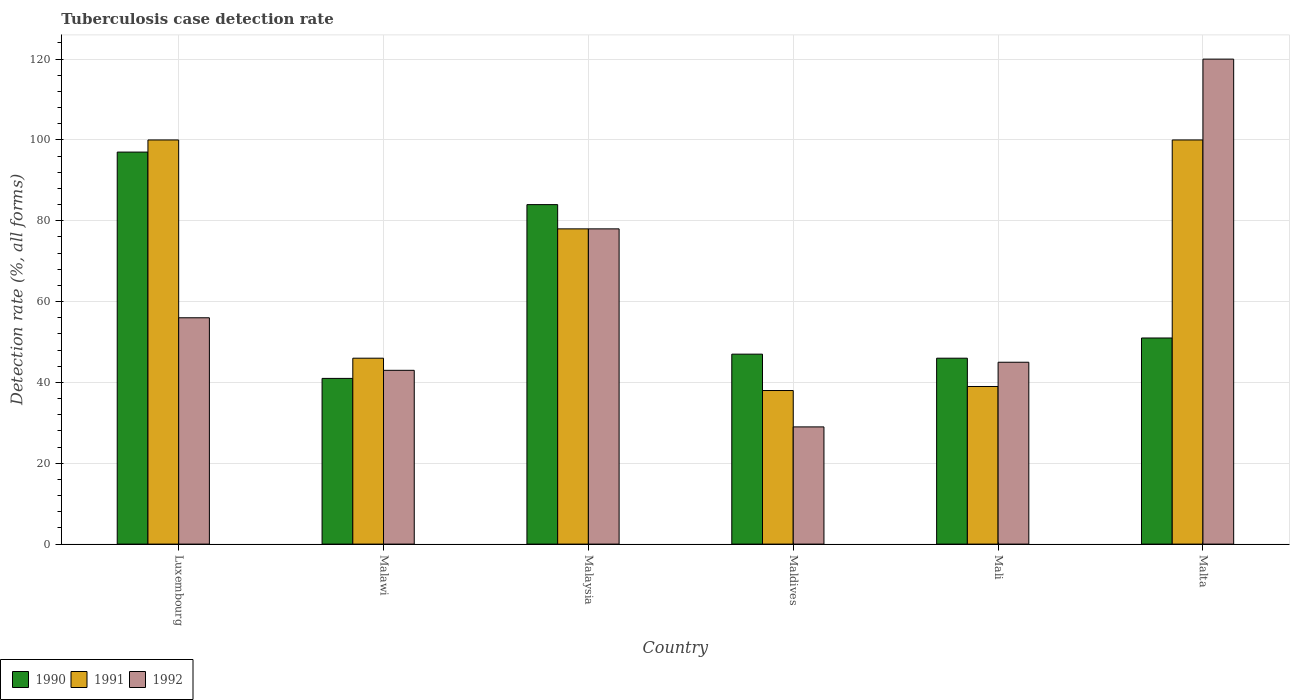How many different coloured bars are there?
Make the answer very short. 3. How many groups of bars are there?
Give a very brief answer. 6. Are the number of bars per tick equal to the number of legend labels?
Offer a terse response. Yes. How many bars are there on the 4th tick from the right?
Keep it short and to the point. 3. What is the label of the 4th group of bars from the left?
Make the answer very short. Maldives. In how many cases, is the number of bars for a given country not equal to the number of legend labels?
Offer a very short reply. 0. Across all countries, what is the maximum tuberculosis case detection rate in in 1992?
Offer a very short reply. 120. Across all countries, what is the minimum tuberculosis case detection rate in in 1992?
Give a very brief answer. 29. In which country was the tuberculosis case detection rate in in 1991 maximum?
Provide a short and direct response. Luxembourg. In which country was the tuberculosis case detection rate in in 1991 minimum?
Provide a short and direct response. Maldives. What is the total tuberculosis case detection rate in in 1991 in the graph?
Keep it short and to the point. 401. What is the difference between the tuberculosis case detection rate in in 1990 in Malaysia and that in Mali?
Make the answer very short. 38. What is the difference between the tuberculosis case detection rate in in 1991 in Luxembourg and the tuberculosis case detection rate in in 1990 in Mali?
Provide a short and direct response. 54. What is the average tuberculosis case detection rate in in 1992 per country?
Your answer should be very brief. 61.83. What is the difference between the tuberculosis case detection rate in of/in 1992 and tuberculosis case detection rate in of/in 1991 in Malawi?
Offer a very short reply. -3. What is the ratio of the tuberculosis case detection rate in in 1990 in Malaysia to that in Mali?
Provide a short and direct response. 1.83. What is the difference between the highest and the second highest tuberculosis case detection rate in in 1990?
Your answer should be very brief. 46. What is the difference between the highest and the lowest tuberculosis case detection rate in in 1991?
Offer a very short reply. 62. How many bars are there?
Offer a very short reply. 18. Are all the bars in the graph horizontal?
Your answer should be very brief. No. Does the graph contain any zero values?
Give a very brief answer. No. Does the graph contain grids?
Give a very brief answer. Yes. Where does the legend appear in the graph?
Provide a short and direct response. Bottom left. How are the legend labels stacked?
Ensure brevity in your answer.  Horizontal. What is the title of the graph?
Offer a terse response. Tuberculosis case detection rate. What is the label or title of the Y-axis?
Make the answer very short. Detection rate (%, all forms). What is the Detection rate (%, all forms) in 1990 in Luxembourg?
Ensure brevity in your answer.  97. What is the Detection rate (%, all forms) in 1991 in Malawi?
Give a very brief answer. 46. What is the Detection rate (%, all forms) in 1992 in Malaysia?
Your response must be concise. 78. What is the Detection rate (%, all forms) of 1990 in Maldives?
Offer a terse response. 47. What is the Detection rate (%, all forms) in 1991 in Maldives?
Give a very brief answer. 38. What is the Detection rate (%, all forms) in 1992 in Maldives?
Offer a terse response. 29. What is the Detection rate (%, all forms) of 1992 in Mali?
Give a very brief answer. 45. What is the Detection rate (%, all forms) in 1992 in Malta?
Offer a terse response. 120. Across all countries, what is the maximum Detection rate (%, all forms) in 1990?
Your response must be concise. 97. Across all countries, what is the maximum Detection rate (%, all forms) in 1992?
Provide a short and direct response. 120. Across all countries, what is the minimum Detection rate (%, all forms) of 1990?
Ensure brevity in your answer.  41. Across all countries, what is the minimum Detection rate (%, all forms) in 1992?
Your answer should be very brief. 29. What is the total Detection rate (%, all forms) of 1990 in the graph?
Give a very brief answer. 366. What is the total Detection rate (%, all forms) of 1991 in the graph?
Your answer should be very brief. 401. What is the total Detection rate (%, all forms) of 1992 in the graph?
Provide a short and direct response. 371. What is the difference between the Detection rate (%, all forms) of 1992 in Luxembourg and that in Malawi?
Give a very brief answer. 13. What is the difference between the Detection rate (%, all forms) in 1990 in Luxembourg and that in Malaysia?
Make the answer very short. 13. What is the difference between the Detection rate (%, all forms) of 1991 in Luxembourg and that in Malaysia?
Offer a very short reply. 22. What is the difference between the Detection rate (%, all forms) of 1992 in Luxembourg and that in Malaysia?
Offer a very short reply. -22. What is the difference between the Detection rate (%, all forms) of 1990 in Luxembourg and that in Maldives?
Make the answer very short. 50. What is the difference between the Detection rate (%, all forms) of 1991 in Luxembourg and that in Maldives?
Your answer should be compact. 62. What is the difference between the Detection rate (%, all forms) of 1991 in Luxembourg and that in Mali?
Offer a terse response. 61. What is the difference between the Detection rate (%, all forms) of 1992 in Luxembourg and that in Malta?
Offer a terse response. -64. What is the difference between the Detection rate (%, all forms) of 1990 in Malawi and that in Malaysia?
Ensure brevity in your answer.  -43. What is the difference between the Detection rate (%, all forms) in 1991 in Malawi and that in Malaysia?
Your answer should be very brief. -32. What is the difference between the Detection rate (%, all forms) in 1992 in Malawi and that in Malaysia?
Your answer should be compact. -35. What is the difference between the Detection rate (%, all forms) in 1990 in Malawi and that in Maldives?
Offer a very short reply. -6. What is the difference between the Detection rate (%, all forms) in 1991 in Malawi and that in Maldives?
Your answer should be compact. 8. What is the difference between the Detection rate (%, all forms) of 1992 in Malawi and that in Maldives?
Your response must be concise. 14. What is the difference between the Detection rate (%, all forms) in 1990 in Malawi and that in Mali?
Offer a very short reply. -5. What is the difference between the Detection rate (%, all forms) of 1991 in Malawi and that in Mali?
Make the answer very short. 7. What is the difference between the Detection rate (%, all forms) of 1990 in Malawi and that in Malta?
Your answer should be very brief. -10. What is the difference between the Detection rate (%, all forms) in 1991 in Malawi and that in Malta?
Your answer should be very brief. -54. What is the difference between the Detection rate (%, all forms) in 1992 in Malawi and that in Malta?
Offer a very short reply. -77. What is the difference between the Detection rate (%, all forms) of 1990 in Malaysia and that in Maldives?
Offer a terse response. 37. What is the difference between the Detection rate (%, all forms) of 1992 in Malaysia and that in Maldives?
Offer a very short reply. 49. What is the difference between the Detection rate (%, all forms) of 1990 in Malaysia and that in Mali?
Provide a succinct answer. 38. What is the difference between the Detection rate (%, all forms) of 1991 in Malaysia and that in Mali?
Offer a terse response. 39. What is the difference between the Detection rate (%, all forms) of 1992 in Malaysia and that in Malta?
Ensure brevity in your answer.  -42. What is the difference between the Detection rate (%, all forms) in 1990 in Maldives and that in Mali?
Provide a succinct answer. 1. What is the difference between the Detection rate (%, all forms) of 1992 in Maldives and that in Mali?
Your answer should be compact. -16. What is the difference between the Detection rate (%, all forms) in 1991 in Maldives and that in Malta?
Offer a very short reply. -62. What is the difference between the Detection rate (%, all forms) of 1992 in Maldives and that in Malta?
Your response must be concise. -91. What is the difference between the Detection rate (%, all forms) in 1990 in Mali and that in Malta?
Your answer should be compact. -5. What is the difference between the Detection rate (%, all forms) of 1991 in Mali and that in Malta?
Make the answer very short. -61. What is the difference between the Detection rate (%, all forms) of 1992 in Mali and that in Malta?
Provide a short and direct response. -75. What is the difference between the Detection rate (%, all forms) in 1990 in Luxembourg and the Detection rate (%, all forms) in 1991 in Malawi?
Keep it short and to the point. 51. What is the difference between the Detection rate (%, all forms) in 1991 in Luxembourg and the Detection rate (%, all forms) in 1992 in Malawi?
Make the answer very short. 57. What is the difference between the Detection rate (%, all forms) of 1991 in Luxembourg and the Detection rate (%, all forms) of 1992 in Malaysia?
Provide a succinct answer. 22. What is the difference between the Detection rate (%, all forms) in 1990 in Luxembourg and the Detection rate (%, all forms) in 1991 in Maldives?
Offer a terse response. 59. What is the difference between the Detection rate (%, all forms) in 1990 in Luxembourg and the Detection rate (%, all forms) in 1992 in Maldives?
Provide a succinct answer. 68. What is the difference between the Detection rate (%, all forms) in 1990 in Luxembourg and the Detection rate (%, all forms) in 1992 in Mali?
Provide a succinct answer. 52. What is the difference between the Detection rate (%, all forms) of 1991 in Luxembourg and the Detection rate (%, all forms) of 1992 in Mali?
Your answer should be very brief. 55. What is the difference between the Detection rate (%, all forms) in 1990 in Luxembourg and the Detection rate (%, all forms) in 1991 in Malta?
Your answer should be compact. -3. What is the difference between the Detection rate (%, all forms) of 1991 in Luxembourg and the Detection rate (%, all forms) of 1992 in Malta?
Your answer should be compact. -20. What is the difference between the Detection rate (%, all forms) of 1990 in Malawi and the Detection rate (%, all forms) of 1991 in Malaysia?
Your answer should be very brief. -37. What is the difference between the Detection rate (%, all forms) in 1990 in Malawi and the Detection rate (%, all forms) in 1992 in Malaysia?
Keep it short and to the point. -37. What is the difference between the Detection rate (%, all forms) of 1991 in Malawi and the Detection rate (%, all forms) of 1992 in Malaysia?
Your response must be concise. -32. What is the difference between the Detection rate (%, all forms) of 1990 in Malawi and the Detection rate (%, all forms) of 1991 in Maldives?
Offer a terse response. 3. What is the difference between the Detection rate (%, all forms) in 1991 in Malawi and the Detection rate (%, all forms) in 1992 in Maldives?
Provide a succinct answer. 17. What is the difference between the Detection rate (%, all forms) of 1990 in Malawi and the Detection rate (%, all forms) of 1992 in Mali?
Your response must be concise. -4. What is the difference between the Detection rate (%, all forms) in 1991 in Malawi and the Detection rate (%, all forms) in 1992 in Mali?
Your response must be concise. 1. What is the difference between the Detection rate (%, all forms) in 1990 in Malawi and the Detection rate (%, all forms) in 1991 in Malta?
Make the answer very short. -59. What is the difference between the Detection rate (%, all forms) in 1990 in Malawi and the Detection rate (%, all forms) in 1992 in Malta?
Make the answer very short. -79. What is the difference between the Detection rate (%, all forms) of 1991 in Malawi and the Detection rate (%, all forms) of 1992 in Malta?
Your response must be concise. -74. What is the difference between the Detection rate (%, all forms) of 1991 in Malaysia and the Detection rate (%, all forms) of 1992 in Maldives?
Your response must be concise. 49. What is the difference between the Detection rate (%, all forms) in 1990 in Malaysia and the Detection rate (%, all forms) in 1991 in Mali?
Keep it short and to the point. 45. What is the difference between the Detection rate (%, all forms) in 1990 in Malaysia and the Detection rate (%, all forms) in 1992 in Mali?
Provide a short and direct response. 39. What is the difference between the Detection rate (%, all forms) in 1991 in Malaysia and the Detection rate (%, all forms) in 1992 in Mali?
Ensure brevity in your answer.  33. What is the difference between the Detection rate (%, all forms) in 1990 in Malaysia and the Detection rate (%, all forms) in 1992 in Malta?
Offer a very short reply. -36. What is the difference between the Detection rate (%, all forms) of 1991 in Malaysia and the Detection rate (%, all forms) of 1992 in Malta?
Give a very brief answer. -42. What is the difference between the Detection rate (%, all forms) of 1990 in Maldives and the Detection rate (%, all forms) of 1991 in Mali?
Keep it short and to the point. 8. What is the difference between the Detection rate (%, all forms) in 1990 in Maldives and the Detection rate (%, all forms) in 1992 in Mali?
Give a very brief answer. 2. What is the difference between the Detection rate (%, all forms) in 1990 in Maldives and the Detection rate (%, all forms) in 1991 in Malta?
Provide a short and direct response. -53. What is the difference between the Detection rate (%, all forms) in 1990 in Maldives and the Detection rate (%, all forms) in 1992 in Malta?
Make the answer very short. -73. What is the difference between the Detection rate (%, all forms) in 1991 in Maldives and the Detection rate (%, all forms) in 1992 in Malta?
Give a very brief answer. -82. What is the difference between the Detection rate (%, all forms) in 1990 in Mali and the Detection rate (%, all forms) in 1991 in Malta?
Make the answer very short. -54. What is the difference between the Detection rate (%, all forms) of 1990 in Mali and the Detection rate (%, all forms) of 1992 in Malta?
Offer a very short reply. -74. What is the difference between the Detection rate (%, all forms) in 1991 in Mali and the Detection rate (%, all forms) in 1992 in Malta?
Provide a short and direct response. -81. What is the average Detection rate (%, all forms) in 1990 per country?
Give a very brief answer. 61. What is the average Detection rate (%, all forms) of 1991 per country?
Give a very brief answer. 66.83. What is the average Detection rate (%, all forms) of 1992 per country?
Your answer should be very brief. 61.83. What is the difference between the Detection rate (%, all forms) of 1990 and Detection rate (%, all forms) of 1991 in Malawi?
Provide a short and direct response. -5. What is the difference between the Detection rate (%, all forms) of 1991 and Detection rate (%, all forms) of 1992 in Malaysia?
Your response must be concise. 0. What is the difference between the Detection rate (%, all forms) in 1990 and Detection rate (%, all forms) in 1991 in Maldives?
Your answer should be compact. 9. What is the difference between the Detection rate (%, all forms) in 1990 and Detection rate (%, all forms) in 1992 in Maldives?
Offer a very short reply. 18. What is the difference between the Detection rate (%, all forms) of 1991 and Detection rate (%, all forms) of 1992 in Maldives?
Offer a terse response. 9. What is the difference between the Detection rate (%, all forms) in 1990 and Detection rate (%, all forms) in 1991 in Mali?
Provide a succinct answer. 7. What is the difference between the Detection rate (%, all forms) in 1991 and Detection rate (%, all forms) in 1992 in Mali?
Make the answer very short. -6. What is the difference between the Detection rate (%, all forms) of 1990 and Detection rate (%, all forms) of 1991 in Malta?
Provide a short and direct response. -49. What is the difference between the Detection rate (%, all forms) in 1990 and Detection rate (%, all forms) in 1992 in Malta?
Provide a succinct answer. -69. What is the difference between the Detection rate (%, all forms) in 1991 and Detection rate (%, all forms) in 1992 in Malta?
Keep it short and to the point. -20. What is the ratio of the Detection rate (%, all forms) in 1990 in Luxembourg to that in Malawi?
Provide a succinct answer. 2.37. What is the ratio of the Detection rate (%, all forms) in 1991 in Luxembourg to that in Malawi?
Provide a short and direct response. 2.17. What is the ratio of the Detection rate (%, all forms) of 1992 in Luxembourg to that in Malawi?
Make the answer very short. 1.3. What is the ratio of the Detection rate (%, all forms) in 1990 in Luxembourg to that in Malaysia?
Keep it short and to the point. 1.15. What is the ratio of the Detection rate (%, all forms) of 1991 in Luxembourg to that in Malaysia?
Offer a very short reply. 1.28. What is the ratio of the Detection rate (%, all forms) in 1992 in Luxembourg to that in Malaysia?
Your response must be concise. 0.72. What is the ratio of the Detection rate (%, all forms) of 1990 in Luxembourg to that in Maldives?
Offer a very short reply. 2.06. What is the ratio of the Detection rate (%, all forms) of 1991 in Luxembourg to that in Maldives?
Give a very brief answer. 2.63. What is the ratio of the Detection rate (%, all forms) of 1992 in Luxembourg to that in Maldives?
Your response must be concise. 1.93. What is the ratio of the Detection rate (%, all forms) of 1990 in Luxembourg to that in Mali?
Give a very brief answer. 2.11. What is the ratio of the Detection rate (%, all forms) of 1991 in Luxembourg to that in Mali?
Give a very brief answer. 2.56. What is the ratio of the Detection rate (%, all forms) in 1992 in Luxembourg to that in Mali?
Ensure brevity in your answer.  1.24. What is the ratio of the Detection rate (%, all forms) of 1990 in Luxembourg to that in Malta?
Make the answer very short. 1.9. What is the ratio of the Detection rate (%, all forms) of 1991 in Luxembourg to that in Malta?
Your answer should be very brief. 1. What is the ratio of the Detection rate (%, all forms) in 1992 in Luxembourg to that in Malta?
Ensure brevity in your answer.  0.47. What is the ratio of the Detection rate (%, all forms) in 1990 in Malawi to that in Malaysia?
Your response must be concise. 0.49. What is the ratio of the Detection rate (%, all forms) in 1991 in Malawi to that in Malaysia?
Provide a succinct answer. 0.59. What is the ratio of the Detection rate (%, all forms) of 1992 in Malawi to that in Malaysia?
Offer a terse response. 0.55. What is the ratio of the Detection rate (%, all forms) in 1990 in Malawi to that in Maldives?
Make the answer very short. 0.87. What is the ratio of the Detection rate (%, all forms) of 1991 in Malawi to that in Maldives?
Your response must be concise. 1.21. What is the ratio of the Detection rate (%, all forms) of 1992 in Malawi to that in Maldives?
Make the answer very short. 1.48. What is the ratio of the Detection rate (%, all forms) in 1990 in Malawi to that in Mali?
Provide a short and direct response. 0.89. What is the ratio of the Detection rate (%, all forms) in 1991 in Malawi to that in Mali?
Make the answer very short. 1.18. What is the ratio of the Detection rate (%, all forms) in 1992 in Malawi to that in Mali?
Your response must be concise. 0.96. What is the ratio of the Detection rate (%, all forms) in 1990 in Malawi to that in Malta?
Give a very brief answer. 0.8. What is the ratio of the Detection rate (%, all forms) in 1991 in Malawi to that in Malta?
Provide a succinct answer. 0.46. What is the ratio of the Detection rate (%, all forms) of 1992 in Malawi to that in Malta?
Your answer should be very brief. 0.36. What is the ratio of the Detection rate (%, all forms) of 1990 in Malaysia to that in Maldives?
Provide a short and direct response. 1.79. What is the ratio of the Detection rate (%, all forms) of 1991 in Malaysia to that in Maldives?
Provide a succinct answer. 2.05. What is the ratio of the Detection rate (%, all forms) in 1992 in Malaysia to that in Maldives?
Ensure brevity in your answer.  2.69. What is the ratio of the Detection rate (%, all forms) of 1990 in Malaysia to that in Mali?
Your answer should be very brief. 1.83. What is the ratio of the Detection rate (%, all forms) in 1992 in Malaysia to that in Mali?
Offer a terse response. 1.73. What is the ratio of the Detection rate (%, all forms) of 1990 in Malaysia to that in Malta?
Provide a short and direct response. 1.65. What is the ratio of the Detection rate (%, all forms) of 1991 in Malaysia to that in Malta?
Your answer should be very brief. 0.78. What is the ratio of the Detection rate (%, all forms) in 1992 in Malaysia to that in Malta?
Offer a terse response. 0.65. What is the ratio of the Detection rate (%, all forms) of 1990 in Maldives to that in Mali?
Offer a terse response. 1.02. What is the ratio of the Detection rate (%, all forms) in 1991 in Maldives to that in Mali?
Provide a short and direct response. 0.97. What is the ratio of the Detection rate (%, all forms) in 1992 in Maldives to that in Mali?
Your response must be concise. 0.64. What is the ratio of the Detection rate (%, all forms) of 1990 in Maldives to that in Malta?
Make the answer very short. 0.92. What is the ratio of the Detection rate (%, all forms) in 1991 in Maldives to that in Malta?
Ensure brevity in your answer.  0.38. What is the ratio of the Detection rate (%, all forms) of 1992 in Maldives to that in Malta?
Offer a very short reply. 0.24. What is the ratio of the Detection rate (%, all forms) of 1990 in Mali to that in Malta?
Ensure brevity in your answer.  0.9. What is the ratio of the Detection rate (%, all forms) of 1991 in Mali to that in Malta?
Your answer should be compact. 0.39. What is the difference between the highest and the lowest Detection rate (%, all forms) of 1991?
Ensure brevity in your answer.  62. What is the difference between the highest and the lowest Detection rate (%, all forms) in 1992?
Keep it short and to the point. 91. 